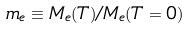Convert formula to latex. <formula><loc_0><loc_0><loc_500><loc_500>m _ { e } \equiv M _ { e } ( T ) / M _ { e } ( T = 0 )</formula> 